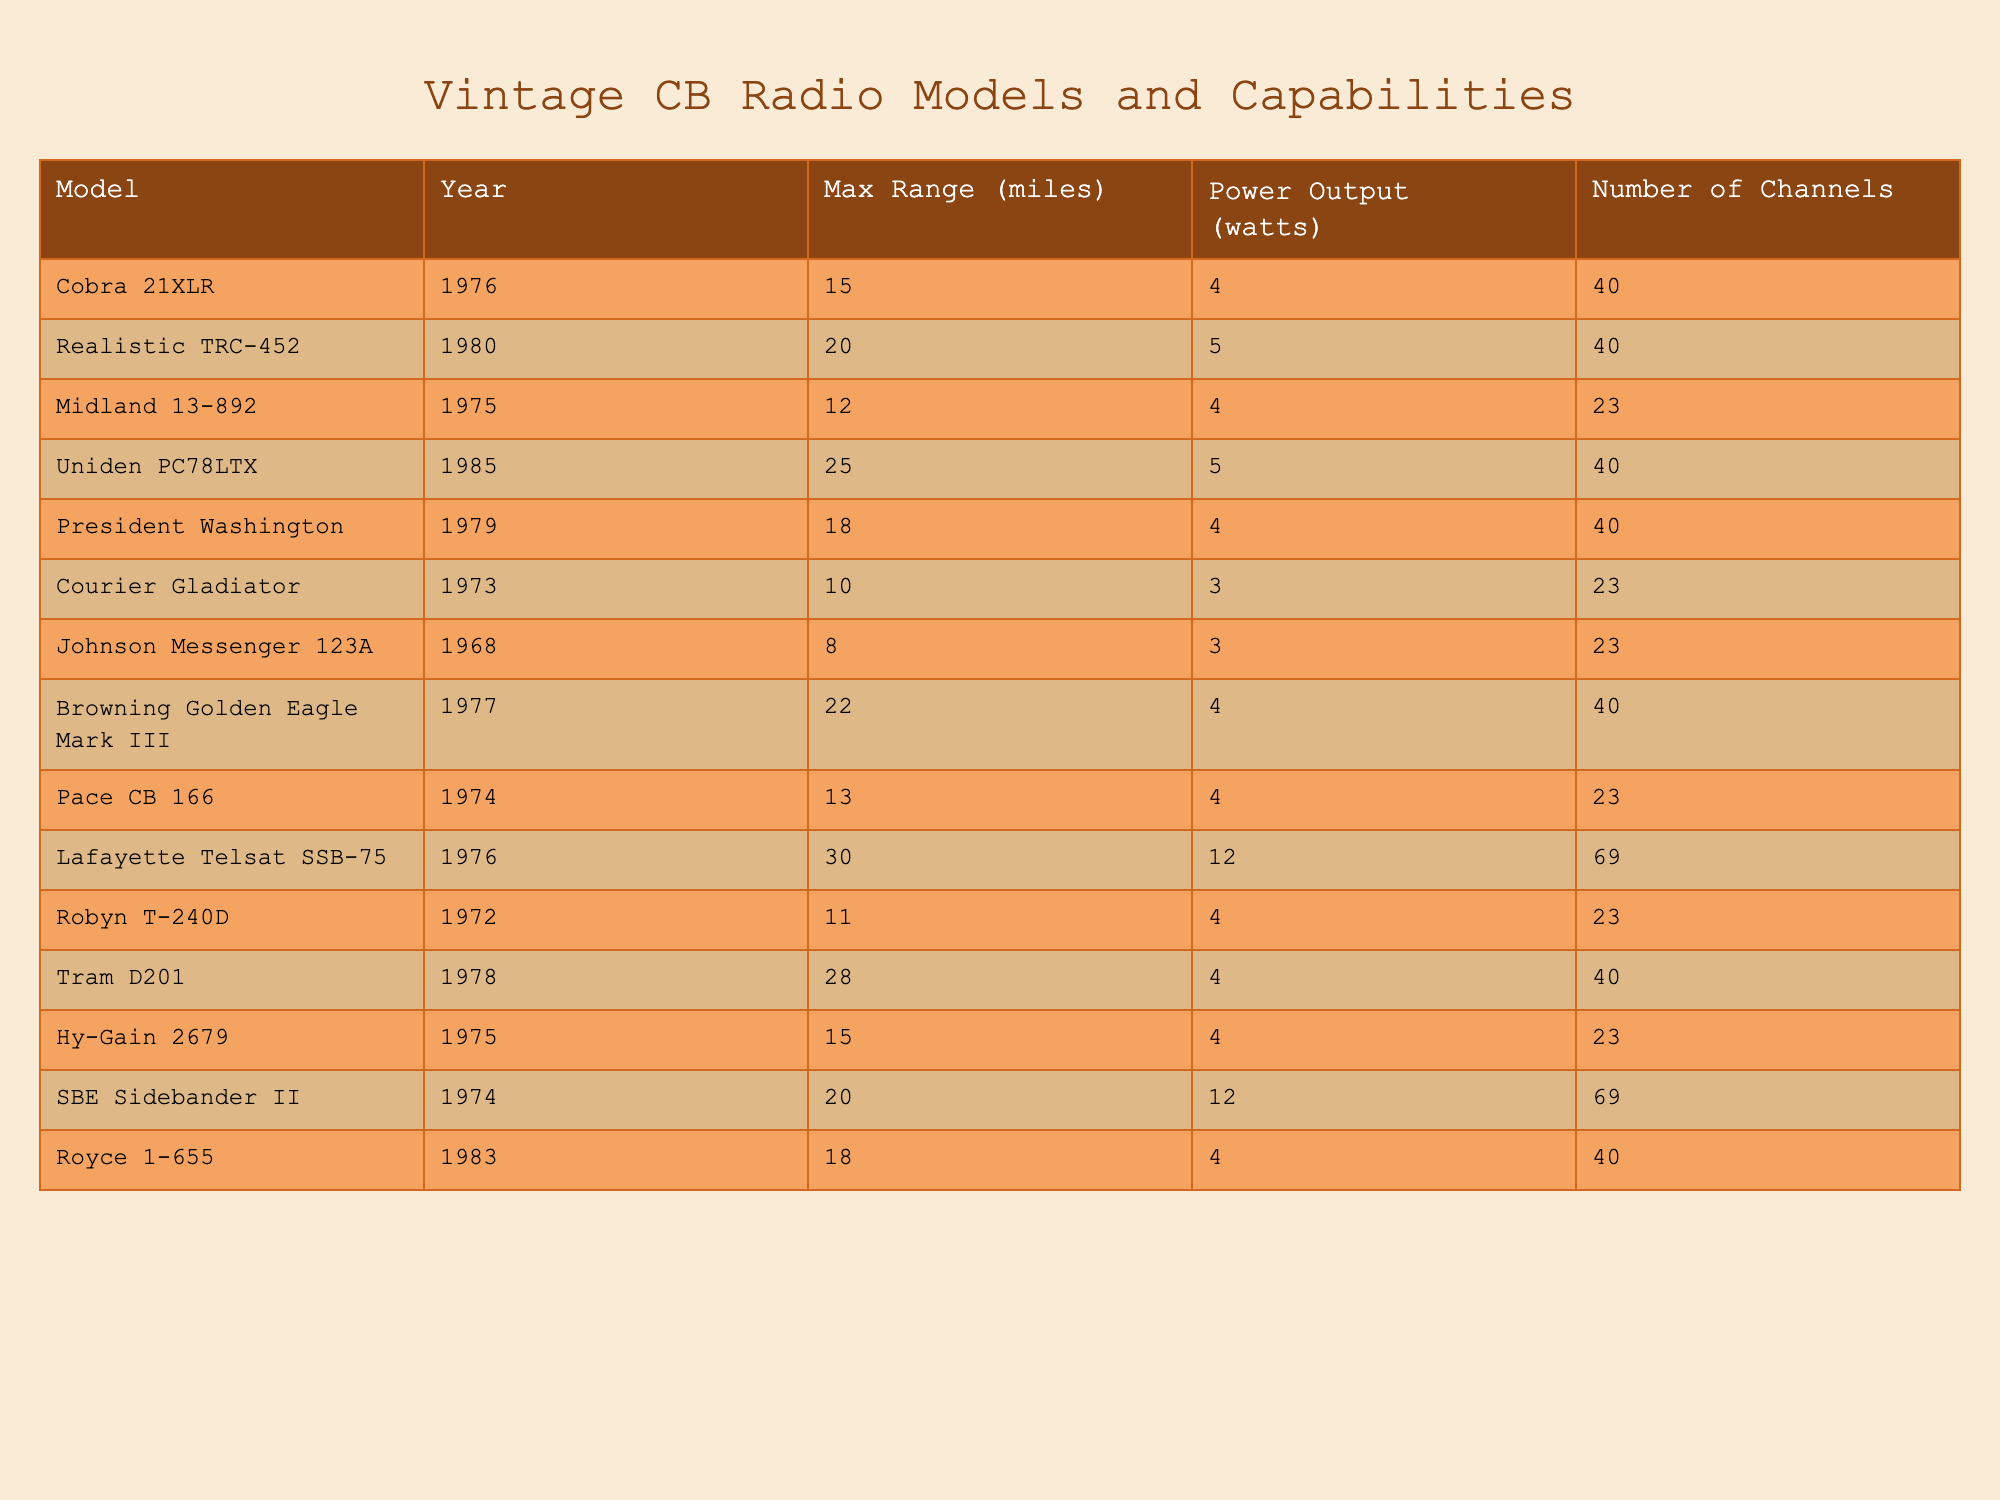What is the maximum range of the Cobra 21XLR model? The Cobra 21XLR model has a maximum range of 15 miles, as indicated in the table under the "Max Range" column.
Answer: 15 miles Which model has the highest maximum range? The Lafayette Telsat SSB-75 model boasts the highest maximum range at 30 miles, which is the highest value in the "Max Range" column of the table.
Answer: 30 miles What is the average maximum range of all the models listed? To find the average, sum the maximum ranges (15 + 20 + 12 + 25 + 18 + 10 + 8 + 22 + 13 + 30 + 11 + 28 + 15 + 20 + 18 =  1 5 6) and divide by the number of models (15), resulting in an average maximum range of approximately 15.73 miles.
Answer: 15.73 miles Is there any model with a maximum range greater than 25 miles? Yes, the Lafayette Telsat SSB-75 (30 miles) and the Tram D201 (28 miles) have maximum ranges greater than 25 miles, as seen in the "Max Range" column.
Answer: Yes How many models have a maximum range of 20 miles or more? There are five models with a maximum range of 20 miles or more: Realistic TRC-452 (20 miles), Uniden PC78LTX (25 miles), Lafayette Telsat SSB-75 (30 miles), Tram D201 (28 miles), and Browning Golden Eagle Mark III (22 miles).
Answer: 5 models Which model has the least power output? The Johnson Messenger 123A, Courier Gladiator, and Robyn T-240D models each have a power output of 3 watts, the lowest among all models listed in the table under the "Power Output" column.
Answer: Johnson Messenger 123A, Courier Gladiator, and Robyn T-240D What is the total power output of all the models combined? Adding the power outputs of all the models together: (4 + 5 + 4 + 5 + 4 + 3 + 3 + 4 + 4 + 12 + 4 + 4 + 4 + 12 + 4 =  6 1) leads to a total power output of 61 watts.
Answer: 61 watts Which model has the most channels? The Lafayette Telsat SSB-75 and SBE Sidebander II models each have 69 channels, which is the highest number of channels listed in the table.
Answer: Lafayette Telsat SSB-75 and SBE Sidebander II Is there a model older than 1970 in the table? Yes, the Johnson Messenger 123A model was released in 1968, which is older than 1970, as shown in the "Year" column.
Answer: Yes What is the difference in maximum range between the highest and lowest models? The difference is calculated by subtracting the maximum range of the Johnson Messenger 123A (8 miles) from the Lafayette Telsat SSB-75 (30 miles), resulting in a difference of 22 miles.
Answer: 22 miles 